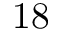Convert formula to latex. <formula><loc_0><loc_0><loc_500><loc_500>1 8</formula> 